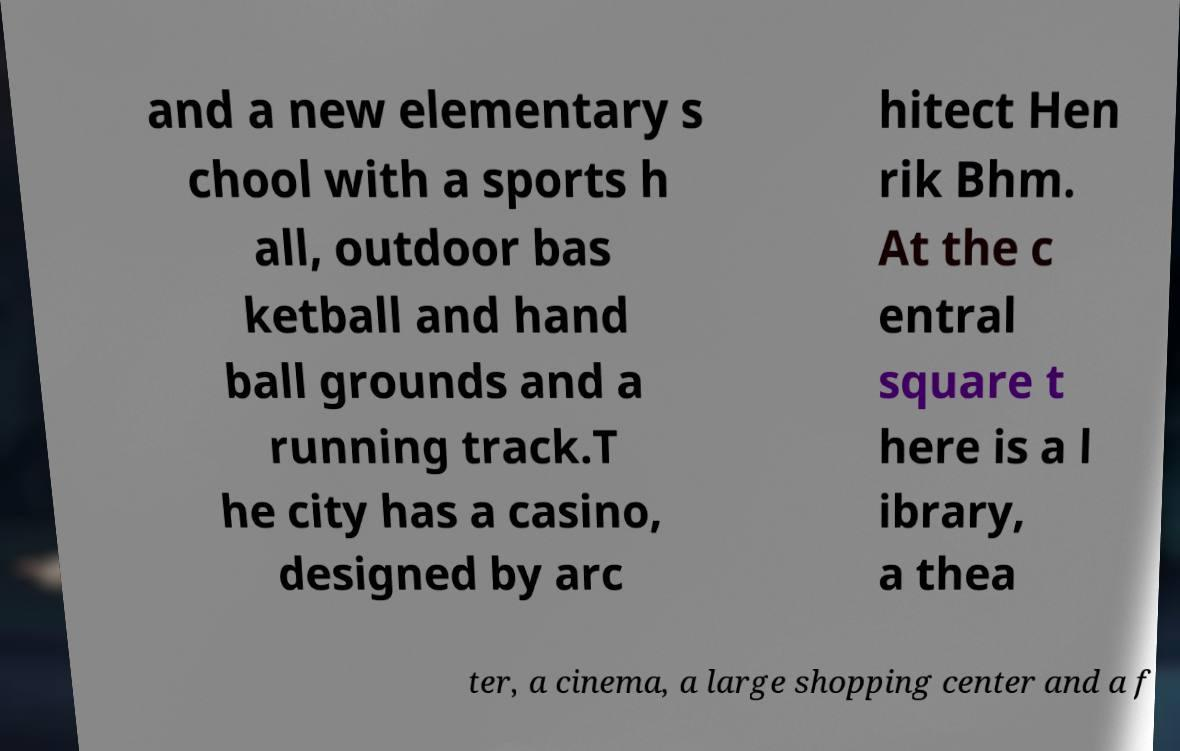What messages or text are displayed in this image? I need them in a readable, typed format. and a new elementary s chool with a sports h all, outdoor bas ketball and hand ball grounds and a running track.T he city has a casino, designed by arc hitect Hen rik Bhm. At the c entral square t here is a l ibrary, a thea ter, a cinema, a large shopping center and a f 